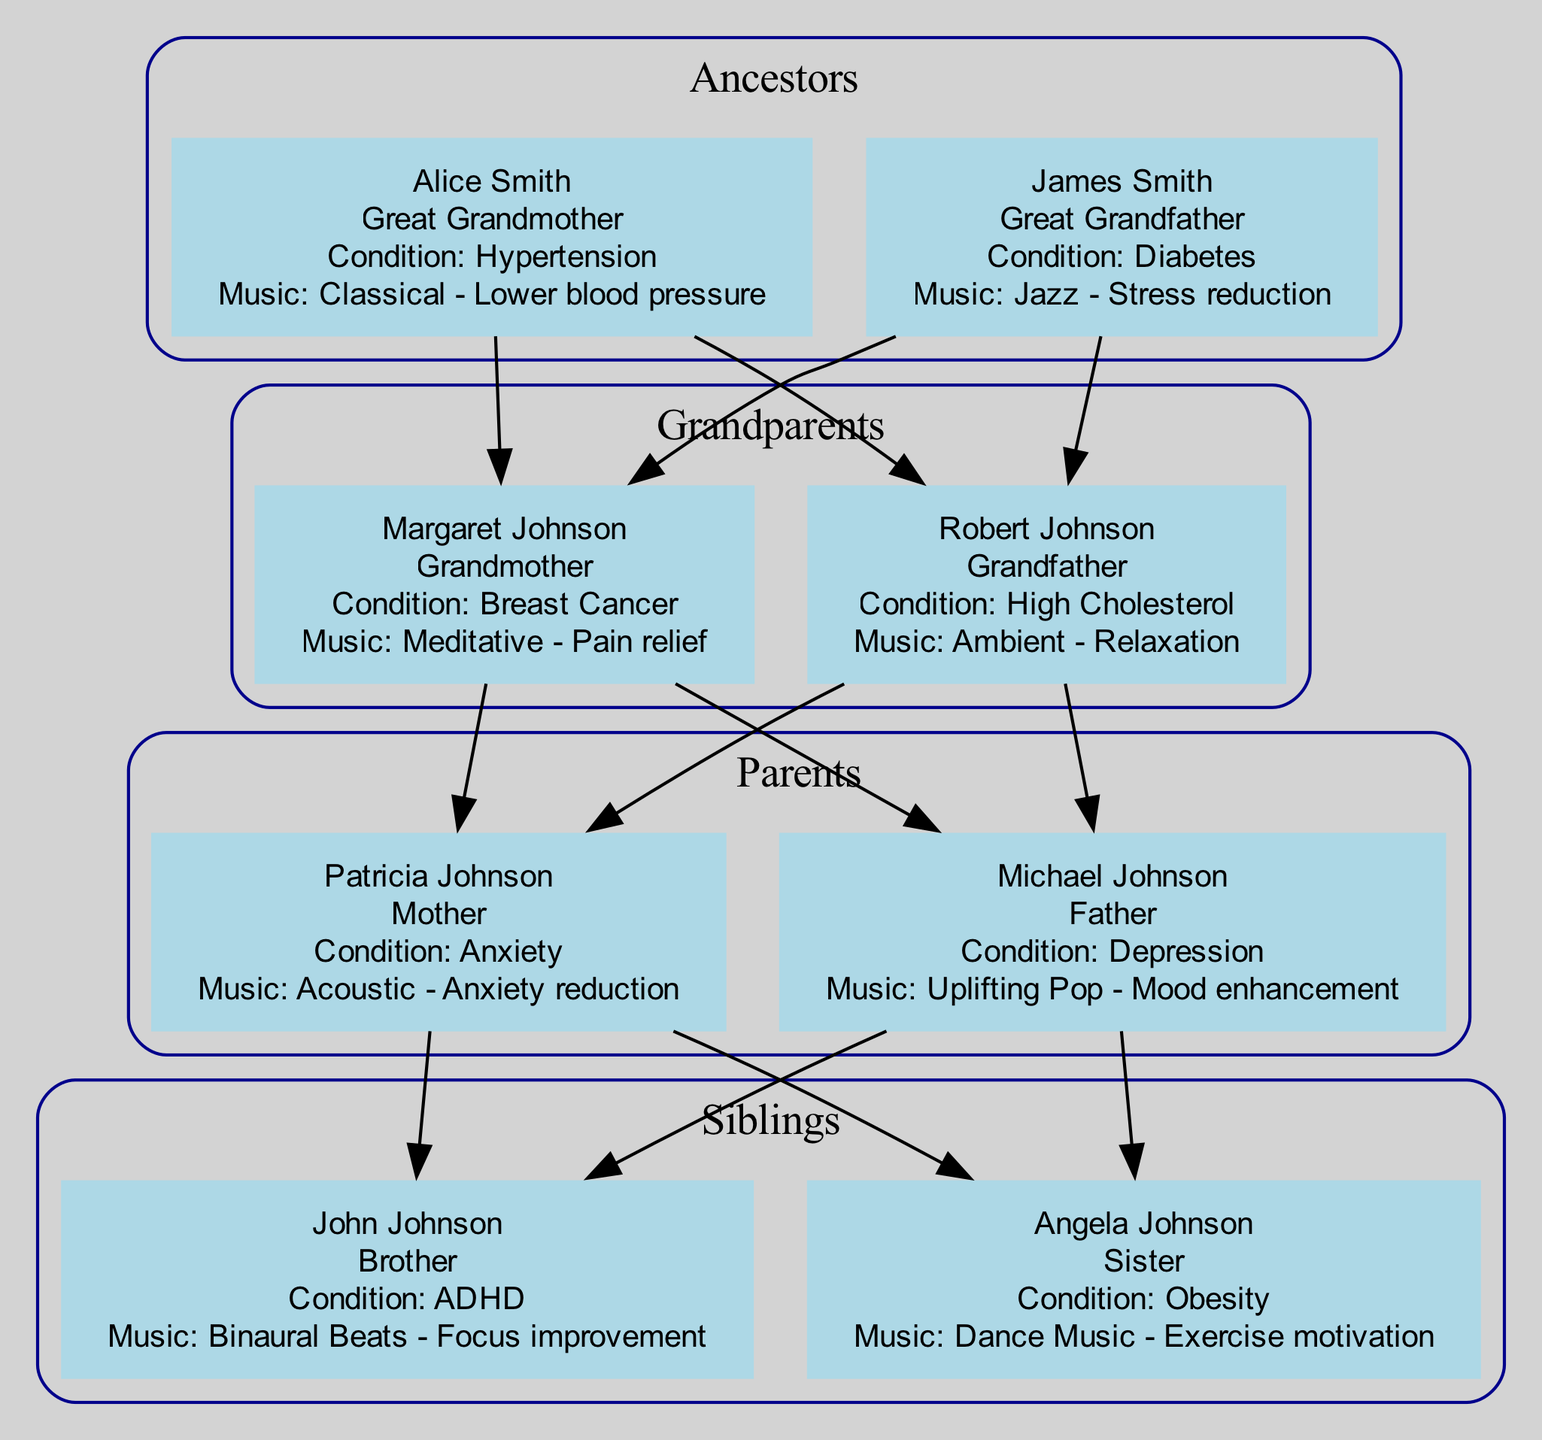What is the health condition of Alice Smith? Alice Smith is listed as the great grandmother in the diagram and has the condition of Hypertension. You can confirm this by locating Alice Smith within the ancestors' section, noting the health condition specified beneath her name.
Answer: Hypertension How many grandparents are shown in the diagram? The grandparents' section of the diagram displays two members: Margaret Johnson and Robert Johnson. Counting these members confirms the total number of grandparents as two.
Answer: 2 What type of therapeutic music is associated with John Johnson? John Johnson, the brother, is indicated to have ADHD as a condition and is associated with Binaural Beats music for focus improvement. This information can be directly extracted from the siblings' section of the diagram.
Answer: Binaural Beats Which family member has the health condition of Anxiety? In the parents' section of the diagram, Patricia Johnson is noted to have Anxiety. By finding Patricia Johnson, you can directly see her associated health condition.
Answer: Anxiety What type of therapeutic music is applied for the health condition of Breast Cancer? Margaret Johnson is identified as the grandmother who has Breast Cancer. Under her information, it specifies that Meditative music is used for pain relief, which directly relates to the management of this condition.
Answer: Meditative Who is associated with High Cholesterol? Robert Johnson is the grandfather who has the health condition of High Cholesterol. You can determine this by looking through the grandparents’ section and identifying his associated health conditions.
Answer: Robert Johnson What is the relationship of Angela Johnson to the family tree? Angela Johnson is labeled as the sister in the siblings' section of the diagram. This can be verified by checking her position and identifying her relationship label.
Answer: Sister What music intervention is used for Depression? Michael Johnson, the father, is associated with Depression and the therapeutic music intervention for this condition is Uplifting Pop aimed at mood enhancement. This information can be found in the parents' section under his details.
Answer: Uplifting Pop Which ancestor has a condition related to Diabetes? James Smith, identified as a great grandfather in the ancestors' section, is shown to have the condition of Diabetes. This can be confirmed by locating his information and checking the listed health conditions.
Answer: James Smith 